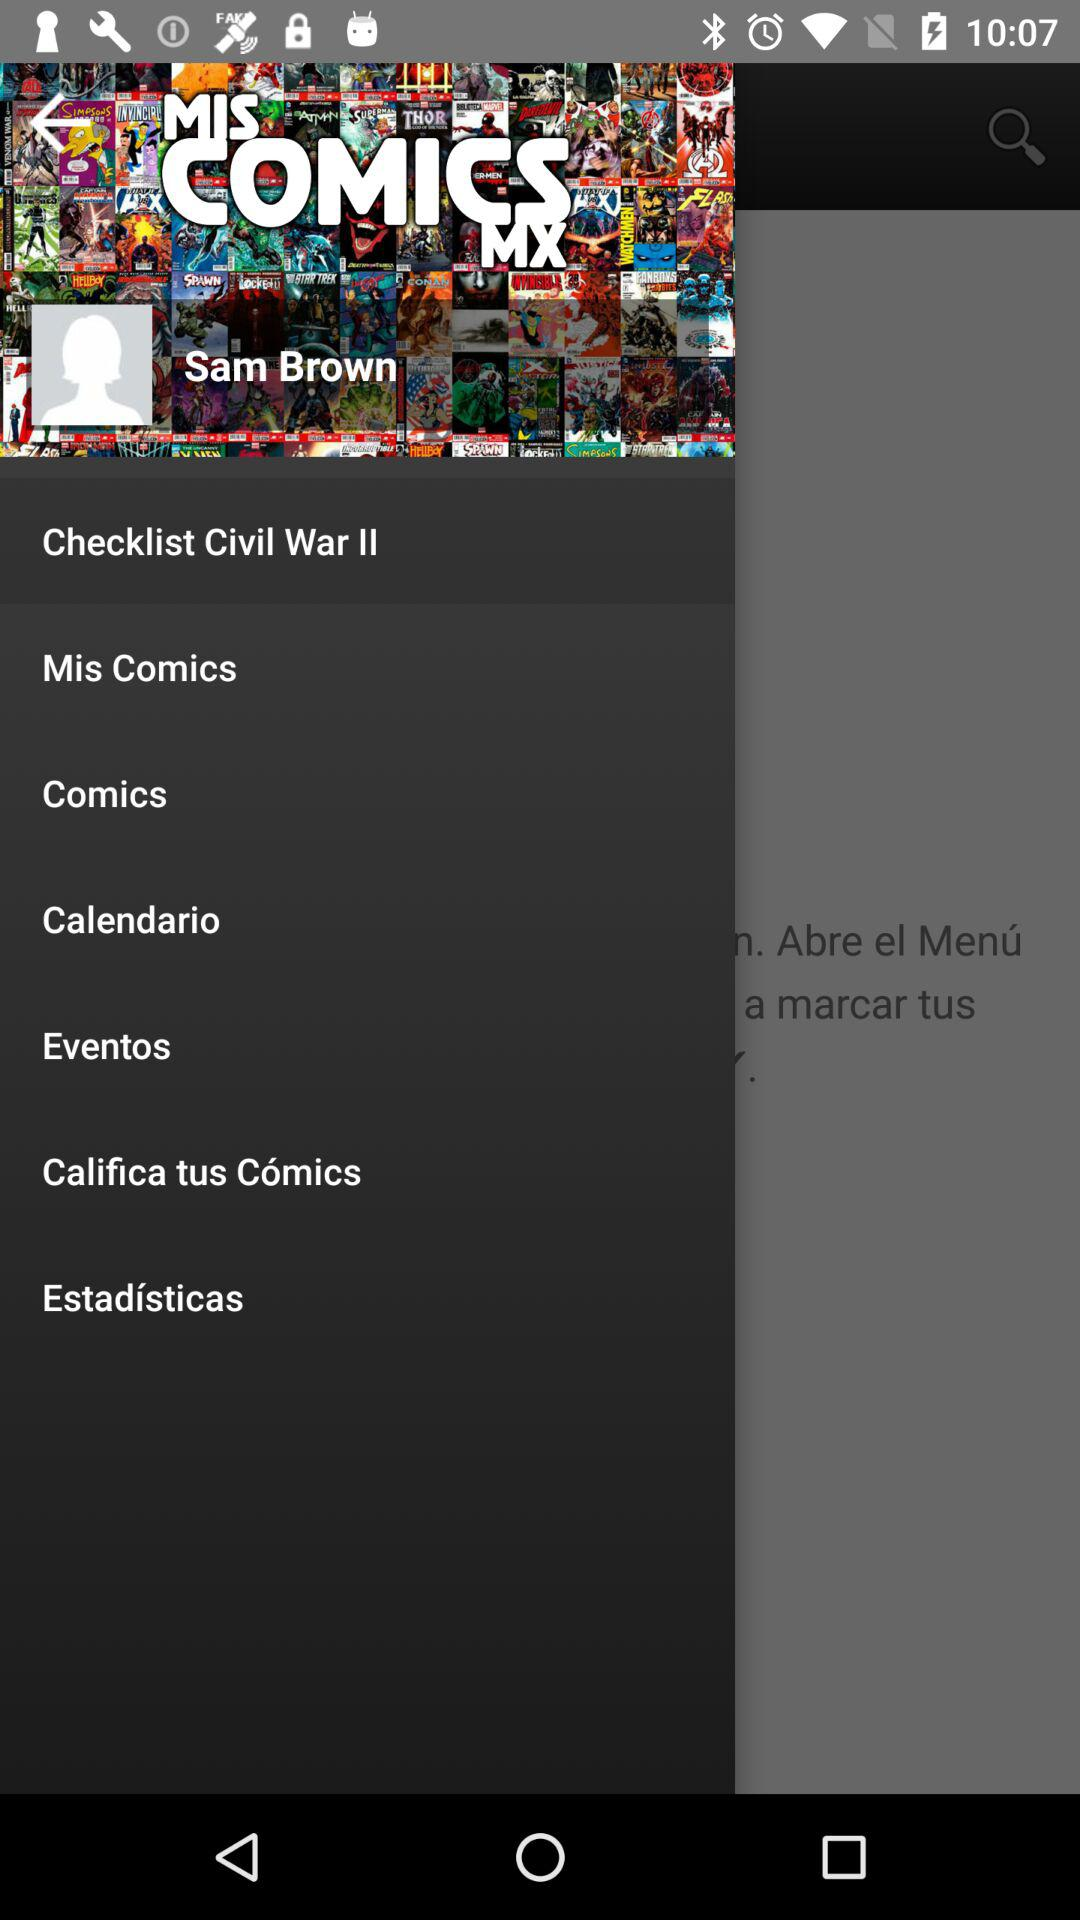How many items are on the main menu?
Answer the question using a single word or phrase. 7 